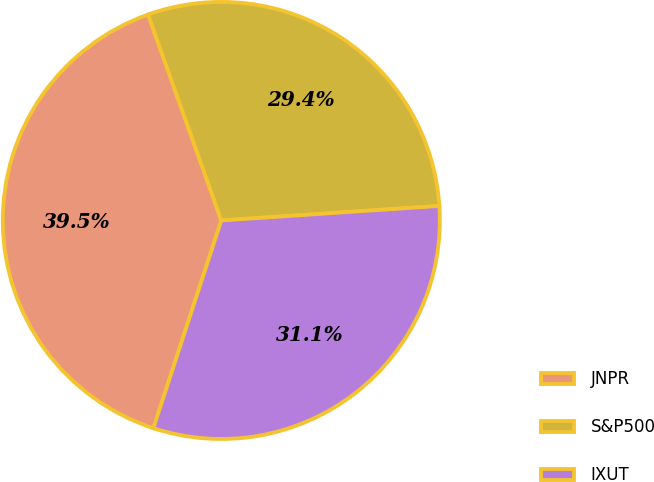<chart> <loc_0><loc_0><loc_500><loc_500><pie_chart><fcel>JNPR<fcel>S&P500<fcel>IXUT<nl><fcel>39.53%<fcel>29.38%<fcel>31.09%<nl></chart> 